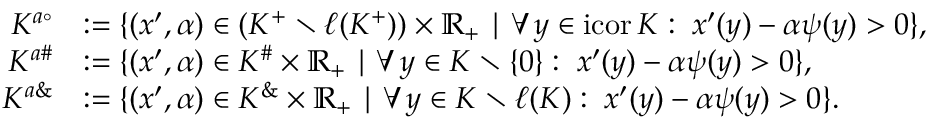<formula> <loc_0><loc_0><loc_500><loc_500>\begin{array} { r l } { K ^ { a \circ } } & { \colon = \{ ( x ^ { \prime } , \alpha ) \in ( K ^ { + } \ \ell ( K ^ { + } ) ) \times \mathbb { R } _ { + } | \forall \, y \in i c o r \, K \colon \, x ^ { \prime } ( y ) - \alpha \psi ( y ) > 0 \} , } \\ { K ^ { a \# } } & { \colon = \{ ( x ^ { \prime } , \alpha ) \in K ^ { \# } \times \mathbb { R } _ { + } | \forall \, y \in K \ \{ 0 \} \colon \, x ^ { \prime } ( y ) - \alpha \psi ( y ) > 0 \} , } \\ { K ^ { a \& } } & { \colon = \{ ( x ^ { \prime } , \alpha ) \in K ^ { \& } \times \mathbb { R } _ { + } | \forall \, y \in K \ \ell ( K ) \colon \, x ^ { \prime } ( y ) - \alpha \psi ( y ) > 0 \} . } \end{array}</formula> 